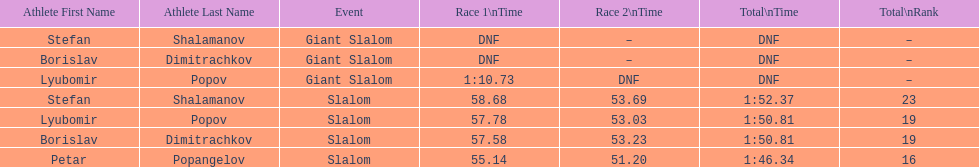Which athlete finished the first race but did not finish the second race? Lyubomir Popov. 